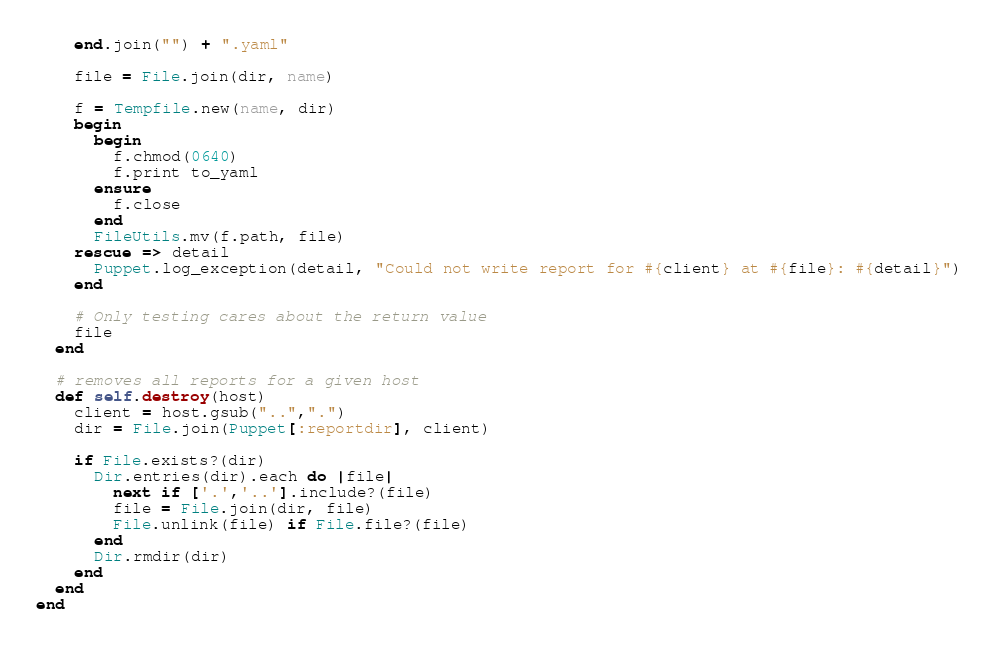<code> <loc_0><loc_0><loc_500><loc_500><_Ruby_>    end.join("") + ".yaml"

    file = File.join(dir, name)

    f = Tempfile.new(name, dir)
    begin
      begin
        f.chmod(0640)
        f.print to_yaml
      ensure
        f.close
      end
      FileUtils.mv(f.path, file)
    rescue => detail
      Puppet.log_exception(detail, "Could not write report for #{client} at #{file}: #{detail}")
    end

    # Only testing cares about the return value
    file
  end

  # removes all reports for a given host
  def self.destroy(host)
    client = host.gsub("..",".")
    dir = File.join(Puppet[:reportdir], client)

    if File.exists?(dir)
      Dir.entries(dir).each do |file|
        next if ['.','..'].include?(file)
        file = File.join(dir, file)
        File.unlink(file) if File.file?(file)
      end
      Dir.rmdir(dir)
    end
  end
end

</code> 